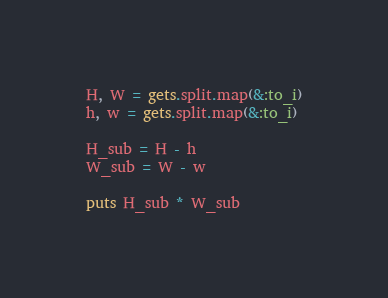Convert code to text. <code><loc_0><loc_0><loc_500><loc_500><_Ruby_>H, W = gets.split.map(&:to_i)
h, w = gets.split.map(&:to_i)

H_sub = H - h
W_sub = W - w

puts H_sub * W_sub</code> 